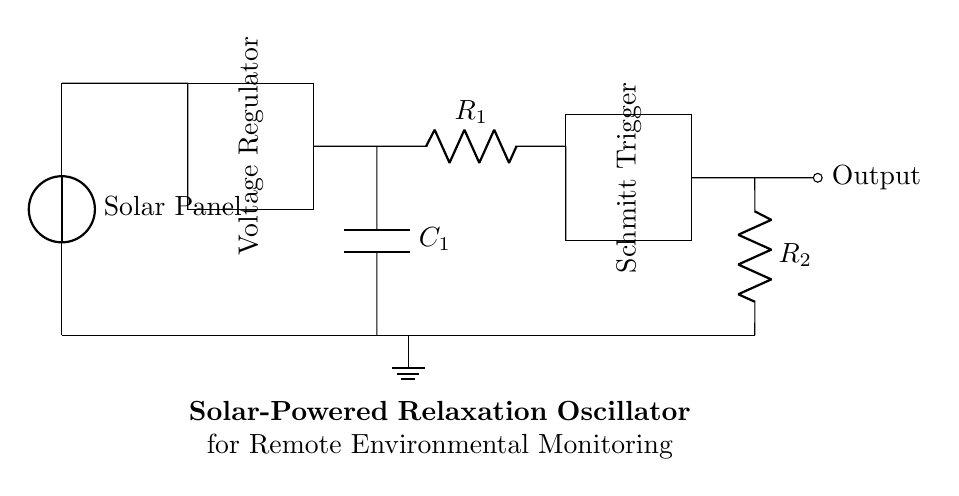What is the power source used in this circuit? The circuit uses a solar panel as its power source, as indicated at the top of the diagram.
Answer: Solar Panel What type of circuit is this? The circuit is a relaxation oscillator, which is designed to generate oscillating signals using hysteresis, often implemented with a Schmitt trigger.
Answer: Relaxation Oscillator What component regulates the voltage? The component that regulates voltage in this circuit is labeled as a Voltage Regulator, which ensures that the voltage remains stable for other components.
Answer: Voltage Regulator What determines the oscillation frequency in this oscillator? The oscillation frequency is primarily determined by the values of the resistor R1 and the capacitor C1, which establish a timing interval for charging and discharging.
Answer: R1 and C1 What component provides feedback for the oscillation? The Schmitt Trigger component provides the necessary feedback and hysteresis, allowing the circuit to switch states and produce oscillations based on the input from capacitor C1.
Answer: Schmitt Trigger How many resistors are present in this circuit? There are two resistors present in the circuit, R1 and R2, as shown in the diagram, both of which are essential for setting the oscillation conditions.
Answer: 2 What is the output type of this oscillator? The output of this solar-powered relaxation oscillator is a pulsed signal, typically provided at the output node indicated in the diagram.
Answer: Pulsed Signal 